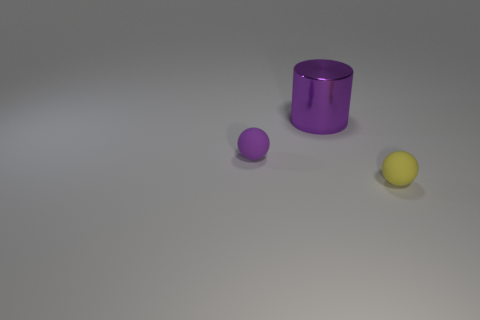The ball on the left side of the small thing in front of the sphere on the left side of the metal thing is made of what material?
Make the answer very short. Rubber. Do the matte thing left of the yellow thing and the tiny matte thing that is right of the large metal cylinder have the same shape?
Your response must be concise. Yes. Is there another metallic cylinder of the same size as the cylinder?
Provide a short and direct response. No. What number of green objects are either tiny matte objects or big things?
Your response must be concise. 0. How many small shiny cylinders have the same color as the metal thing?
Provide a short and direct response. 0. Is there anything else that has the same shape as the large object?
Make the answer very short. No. What number of balls are either rubber objects or purple objects?
Keep it short and to the point. 2. There is a small sphere behind the tiny yellow object; what color is it?
Give a very brief answer. Purple. There is a purple rubber object that is the same size as the yellow rubber sphere; what shape is it?
Ensure brevity in your answer.  Sphere. How many rubber things are left of the purple metal object?
Provide a short and direct response. 1. 